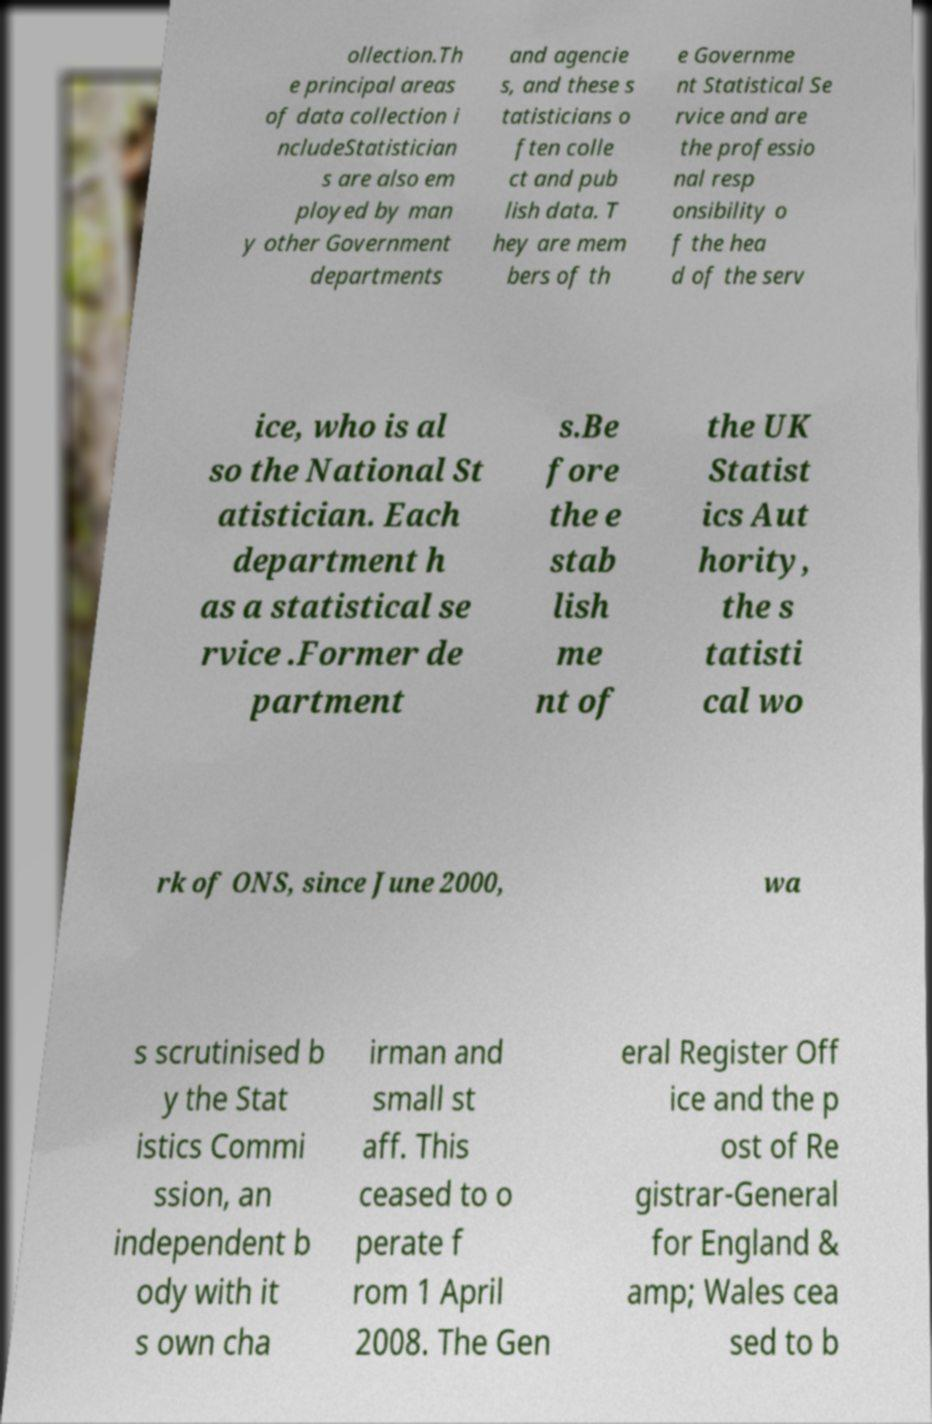Could you assist in decoding the text presented in this image and type it out clearly? ollection.Th e principal areas of data collection i ncludeStatistician s are also em ployed by man y other Government departments and agencie s, and these s tatisticians o ften colle ct and pub lish data. T hey are mem bers of th e Governme nt Statistical Se rvice and are the professio nal resp onsibility o f the hea d of the serv ice, who is al so the National St atistician. Each department h as a statistical se rvice .Former de partment s.Be fore the e stab lish me nt of the UK Statist ics Aut hority, the s tatisti cal wo rk of ONS, since June 2000, wa s scrutinised b y the Stat istics Commi ssion, an independent b ody with it s own cha irman and small st aff. This ceased to o perate f rom 1 April 2008. The Gen eral Register Off ice and the p ost of Re gistrar-General for England & amp; Wales cea sed to b 